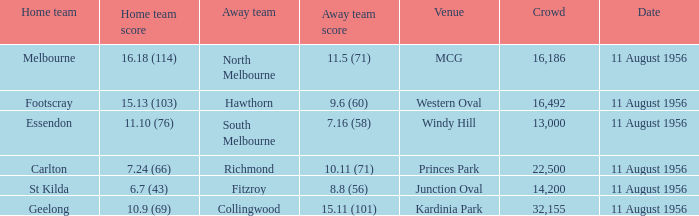18 (114)? Melbourne. Would you be able to parse every entry in this table? {'header': ['Home team', 'Home team score', 'Away team', 'Away team score', 'Venue', 'Crowd', 'Date'], 'rows': [['Melbourne', '16.18 (114)', 'North Melbourne', '11.5 (71)', 'MCG', '16,186', '11 August 1956'], ['Footscray', '15.13 (103)', 'Hawthorn', '9.6 (60)', 'Western Oval', '16,492', '11 August 1956'], ['Essendon', '11.10 (76)', 'South Melbourne', '7.16 (58)', 'Windy Hill', '13,000', '11 August 1956'], ['Carlton', '7.24 (66)', 'Richmond', '10.11 (71)', 'Princes Park', '22,500', '11 August 1956'], ['St Kilda', '6.7 (43)', 'Fitzroy', '8.8 (56)', 'Junction Oval', '14,200', '11 August 1956'], ['Geelong', '10.9 (69)', 'Collingwood', '15.11 (101)', 'Kardinia Park', '32,155', '11 August 1956']]} 